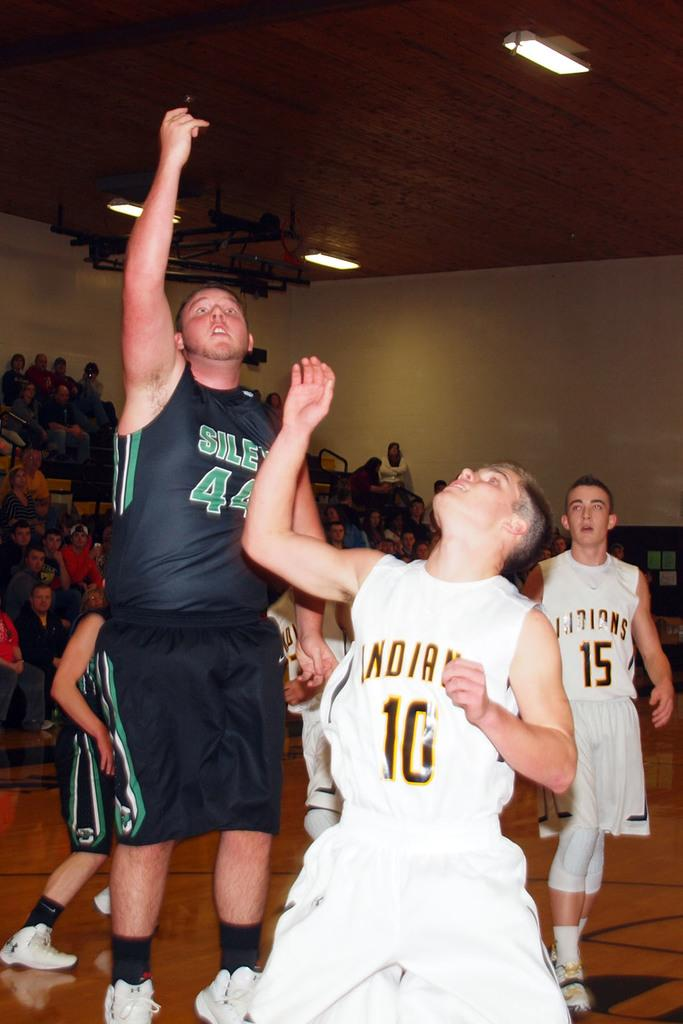Provide a one-sentence caption for the provided image. The Indians may or may not win their basketball game. 